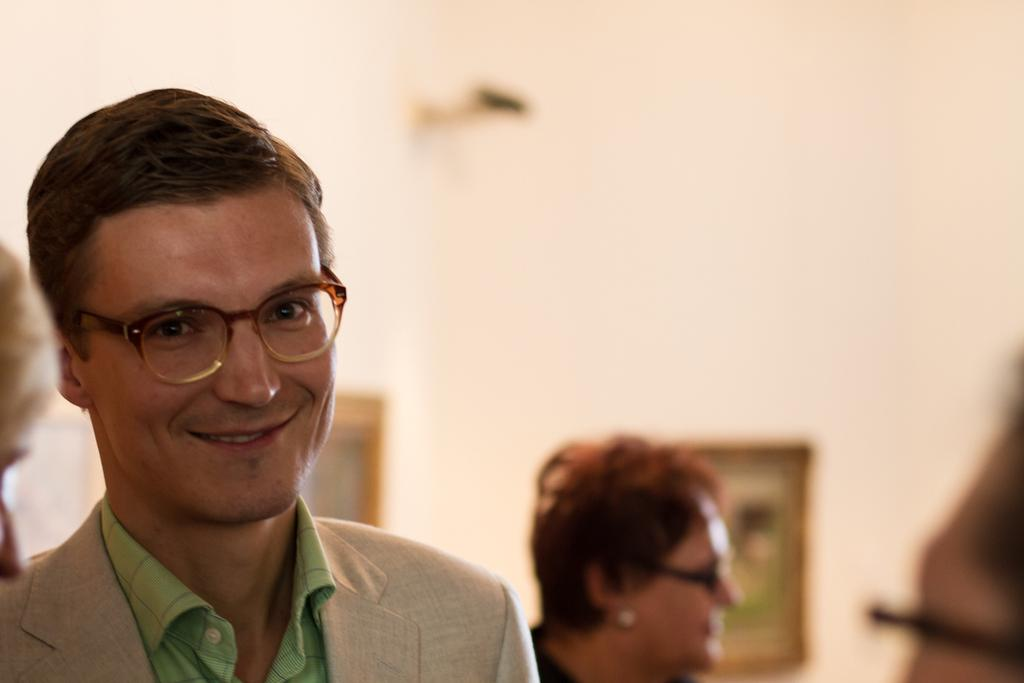What can be seen in the image? There are people in the image, including a man. Can you describe the man in the image? The man is smiling and wearing spectacles. What is the condition of the background in the image? The background of the image is blurry. What can be seen on the wall in the background of the image? There are frames on the wall in the background of the image. What type of caption is written on the sock in the image? There is no sock present in the image, so there is no caption to describe. 